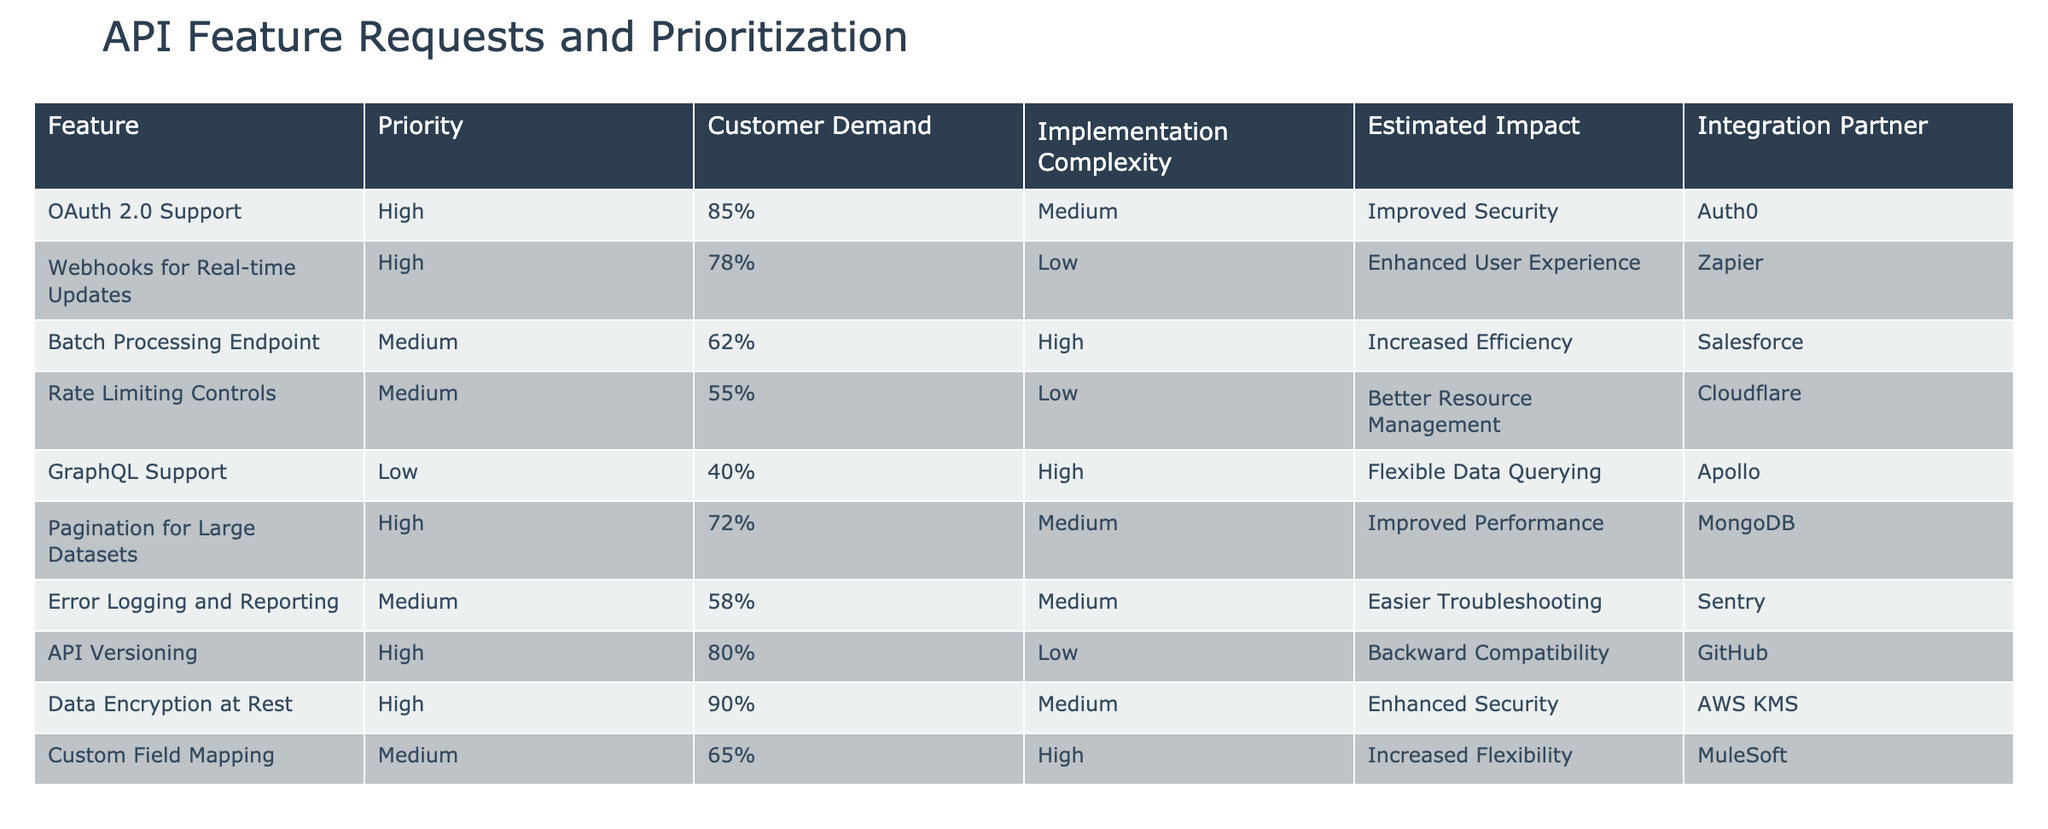What is the priority level for OAuth 2.0 Support? The table indicates that the priority level for OAuth 2.0 Support is listed as High.
Answer: High Which feature has the highest customer demand percentage? By examining the 'Customer Demand' column, Data Encryption at Rest has the highest value at 90%.
Answer: 90% Is Rate Limiting Controls considered a high-priority feature? According to the table, Rate Limiting Controls has a priority level of Medium, so it is not considered high priority.
Answer: No What features have a low implementation complexity? The features with low implementation complexity are Webhooks for Real-time Updates, Rate Limiting Controls, API Versioning, and Data Encryption at Rest.
Answer: Four features What is the average customer demand percentage for Medium priority features? The Medium priority features are Batch Processing Endpoint (62%), Rate Limiting Controls (55%), Error Logging and Reporting (58%), and Custom Field Mapping (65%). Summing these gives 62 + 55 + 58 + 65 = 240. There are 4 features, so the average is 240/4 = 60%.
Answer: 60% Which integration partner is associated with the feature that has the lowest customer demand? GraphQL Support has the lowest customer demand at 40%, and it is associated with the integration partner Apollo.
Answer: Apollo How many features are categorized as high priority? The table shows that there are five features listed with a high priority (OAuth 2.0 Support, Webhooks for Real-time Updates, Pagination for Large Datasets, API Versioning, Data Encryption at Rest). Counting these provides the answer.
Answer: Five features Which feature provides enhanced security and has high customer demand? Looking at the features, Data Encryption at Rest not only provides enhanced security but also has the highest customer demand of 90%.
Answer: Data Encryption at Rest What percentage of high-priority features also have medium implementation complexity? Examining the high-priority features, we see OAuth 2.0 Support, Webhooks for Real-time Updates, Pagination for Large Datasets, API Versioning, and Data Encryption at Rest. Out of these, three features (OAuth 2.0 Support, Pagination for Large Datasets, and Data Encryption at Rest) have medium implementation complexity. Therefore, 3 out of 5 gives us 60%.
Answer: 60% 